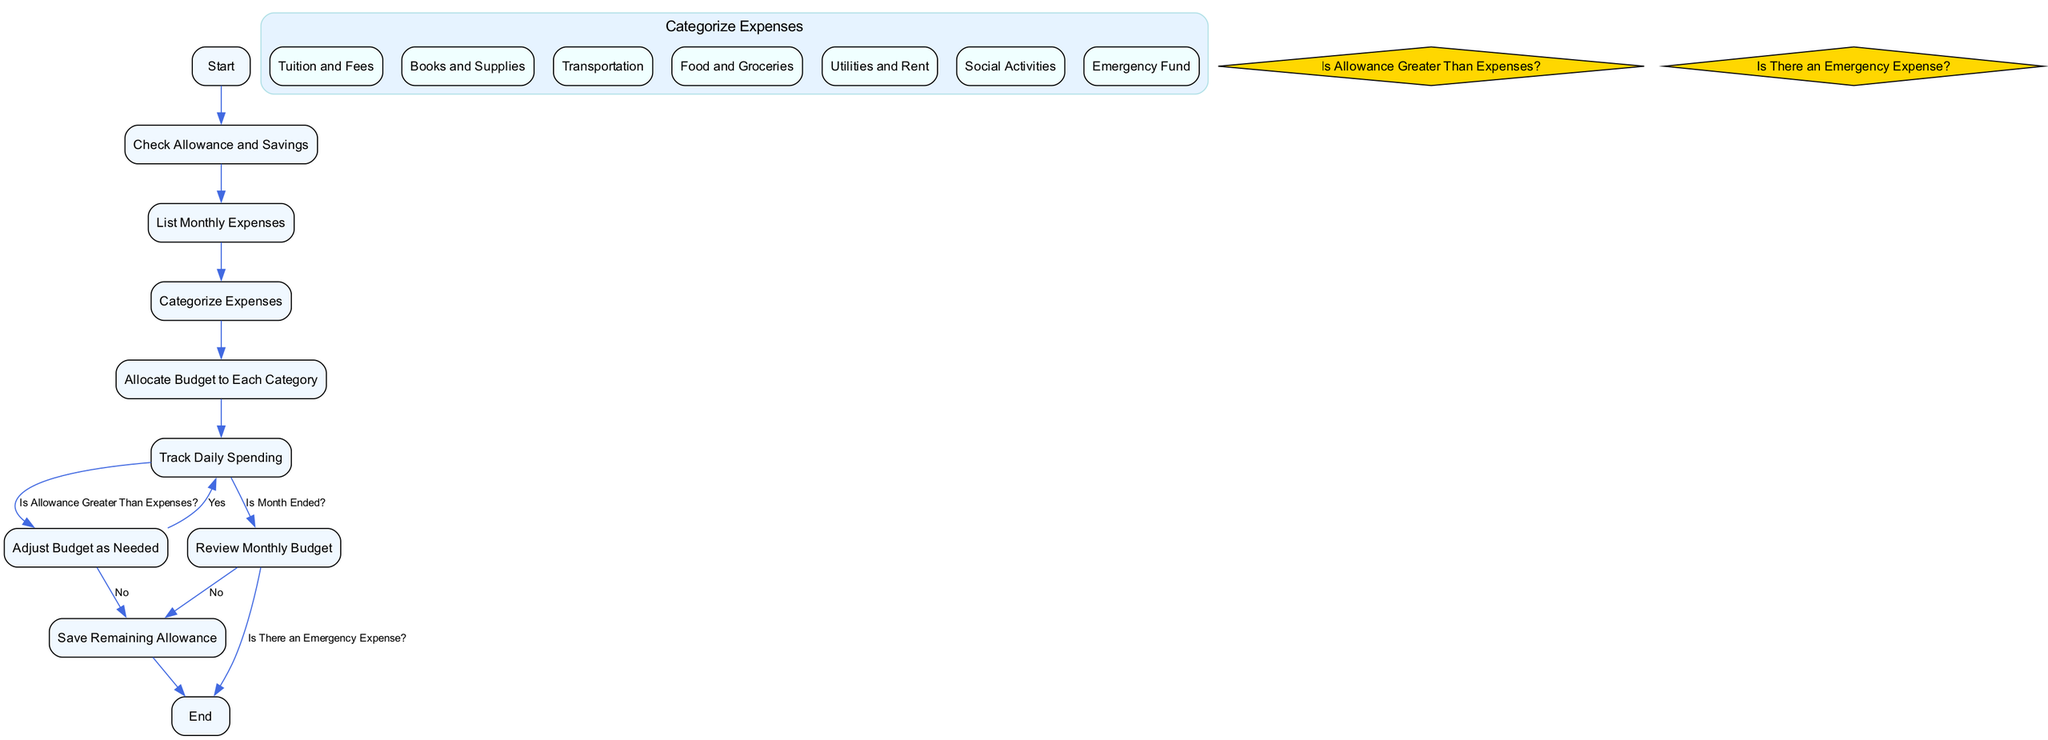What is the first activity in the diagram? The first activity is indicated by the "Start" node, which is the initial point of the diagram.
Answer: Start How many categories of expenses are there? The diagram includes a subactivity section under "Categorize Expenses," listing seven categories: Tuition and Fees, Books and Supplies, Transportation, Food and Groceries, Utilities and Rent, Social Activities, Emergency Fund.
Answer: Seven What decision is made after tracking daily spending? The decision made is "Is Allowance Greater Than Expenses?" which filters the next step based on whether the allowance can cover the expenses or not.
Answer: Is Allowance Greater Than Expenses? If the answer is "Yes" to the decision about allowance and expenses, what is the next activity? If the answer is "Yes," the flow returns to "Track Daily Spending," meaning the budget remains the same, and the student keeps monitoring their spending.
Answer: Track Daily Spending What activity occurs after allocating the budget to each category? After "Allocate Budget to Each Category," the next activity is "Track Daily Spending," where the student monitors their actual expenses against the budgeted amounts.
Answer: Track Daily Spending How does the process end in the diagram? The process ends at the "End" node, which is reached either after reviewing the monthly budget or saving the remaining allowance, depending on previous decisions.
Answer: End What happens if "Is There an Emergency Expense?" is answered positively during the review? If "Is There an Emergency Expense?" is answered positively, the flow moves directly to the "End," indicating a quick resolution to emergency financial needs without further alteration to the budget.
Answer: End What is the last activity before the process concludes? The last activity before concluding the process is "Save Remaining Allowance," which is reached if there are no emergency expenses after reviewing the monthly budget.
Answer: Save Remaining Allowance 